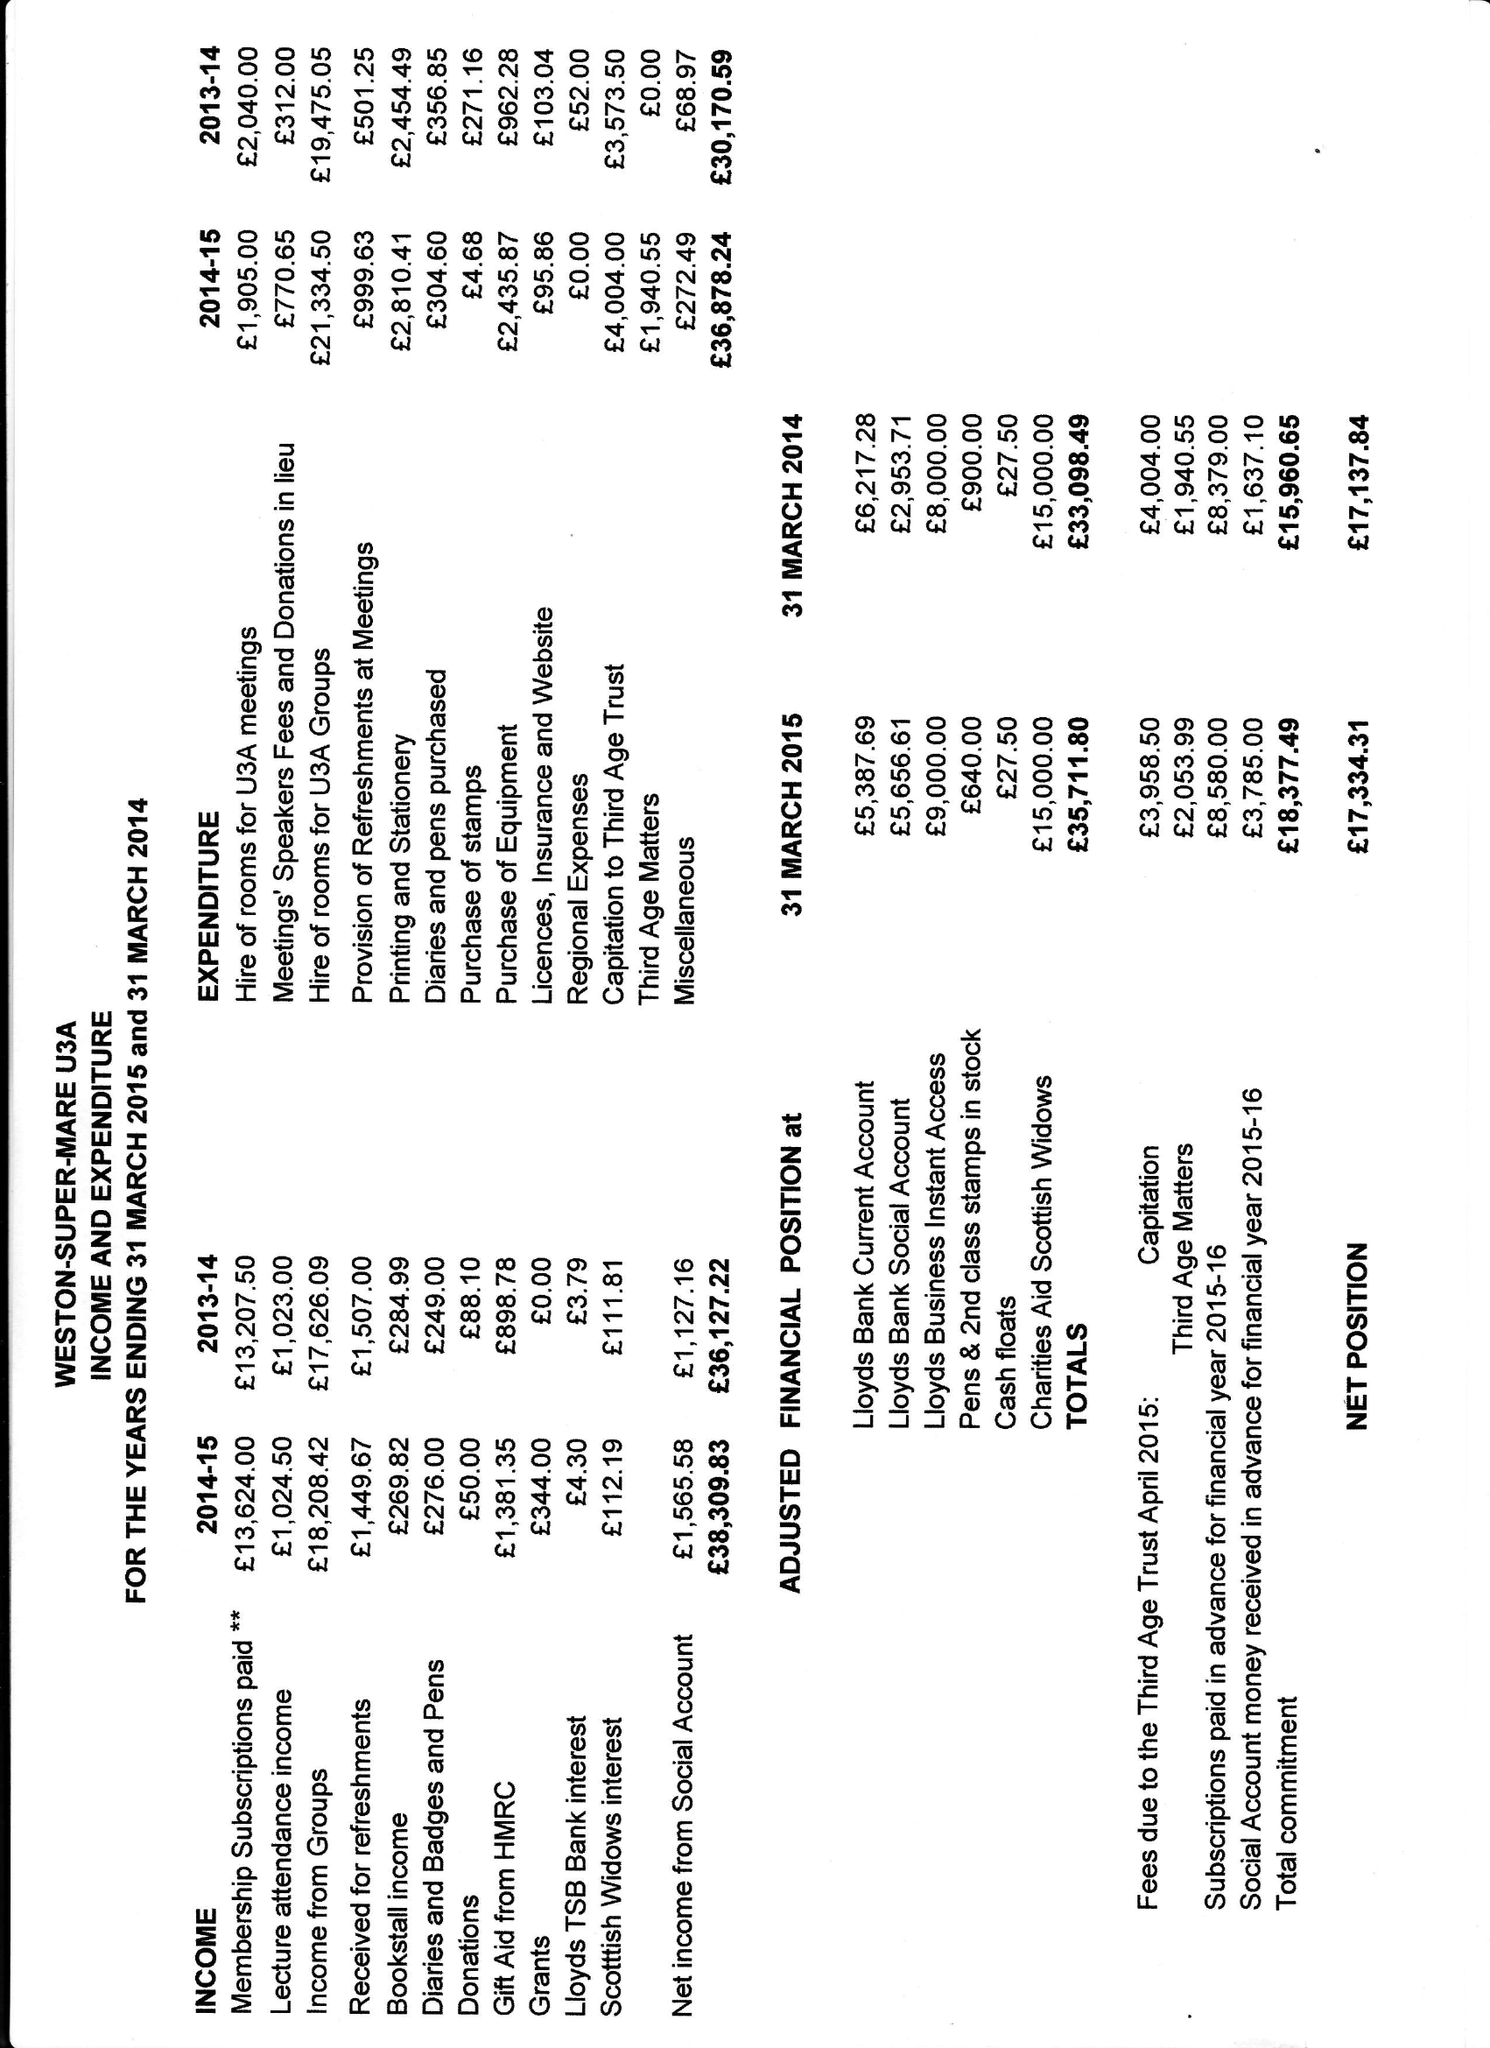What is the value for the charity_name?
Answer the question using a single word or phrase. Weston-Super-Mare U3a 